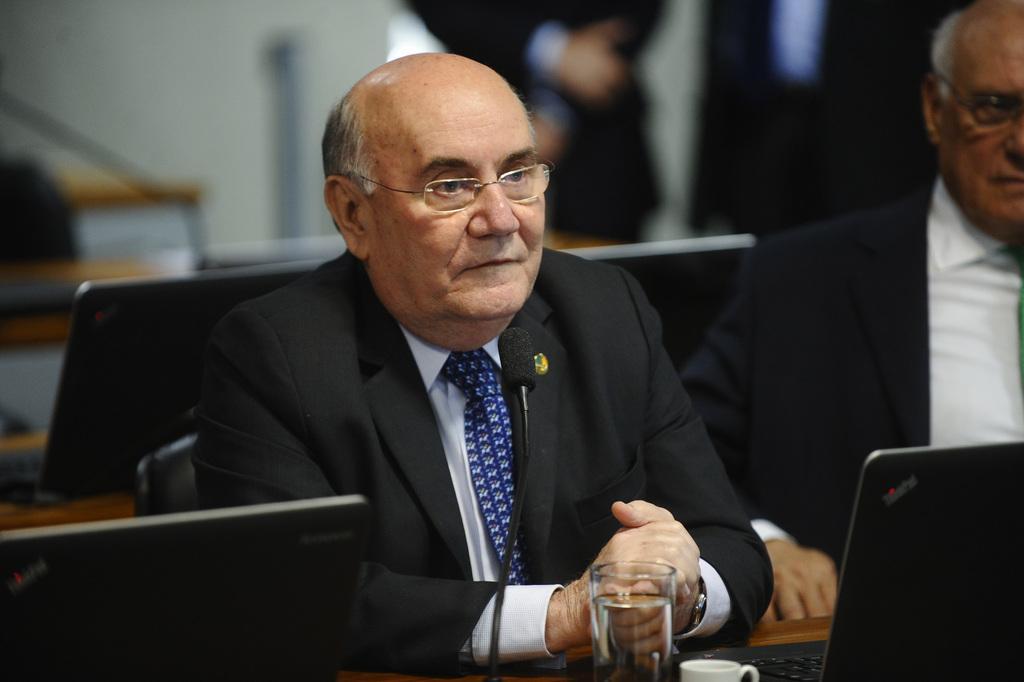Please provide a concise description of this image. In the image we can see two men sitting, wearing clothes and spectacles. Here we can see the systems, glass, tea cup, desk and the background is blurred. 